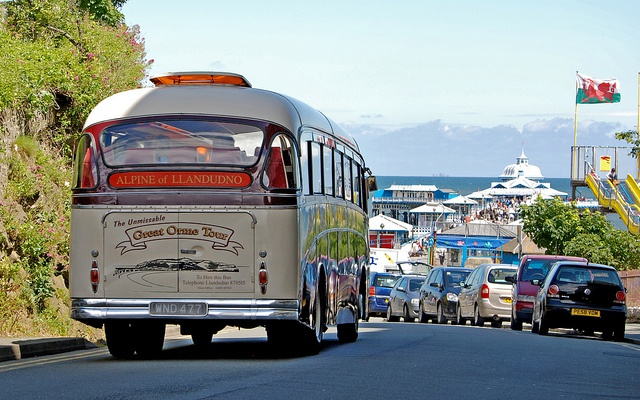Describe the objects in this image and their specific colors. I can see bus in lightblue, darkgray, gray, and black tones, car in lightblue, black, gray, navy, and blue tones, car in lightblue, darkgray, white, gray, and black tones, car in lightblue, black, gray, navy, and blue tones, and car in lightblue, black, gray, and darkgray tones in this image. 